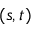<formula> <loc_0><loc_0><loc_500><loc_500>( s , t )</formula> 